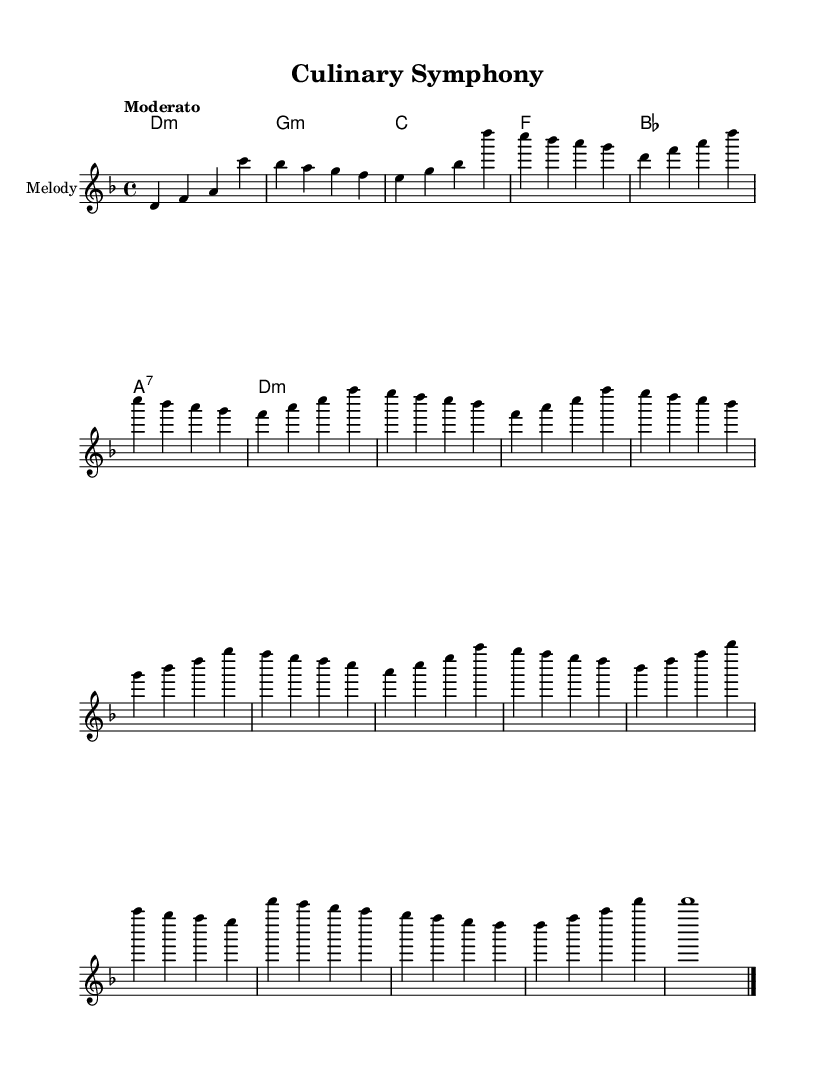What is the key signature of this music? The key signature is indicated by the `\key d \minor` command, which shows that the piece is in D minor.
Answer: D minor What is the time signature of the piece? The time signature is provided by the `\time 4/4` command, which indicates that there are four beats in a measure, and each quarter note gets one beat.
Answer: 4/4 What is the tempo marking for the piece? The tempo marking appears with the `\tempo "Moderato"` command, suggesting that the piece should be played at a moderate speed.
Answer: Moderato How many sections are in the composition? By analyzing the structure of the piece, which includes Introduction, Verse, Chorus, Bridge, and Outro, we can count a total of five distinct sections.
Answer: Five What is the name of the musical instrument for the melody? The instrument name is specified in the `\with { instrumentName = "Melody" }` line, indicating that the melody will be played on an unspecified instrument labeled as "Melody."
Answer: Melody What chord comes after the D minor in the harmonic progression? The command shows a chord progression starting with `d1:m`, and the next chord is specified as `g:m`, which means G minor follows D minor.
Answer: G minor 